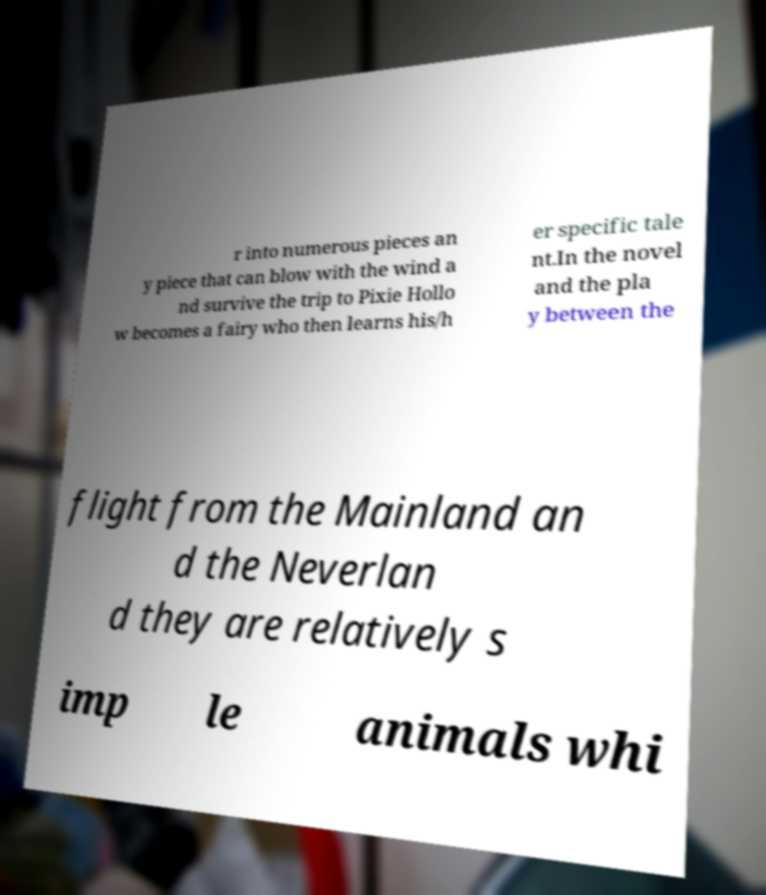For documentation purposes, I need the text within this image transcribed. Could you provide that? r into numerous pieces an y piece that can blow with the wind a nd survive the trip to Pixie Hollo w becomes a fairy who then learns his/h er specific tale nt.In the novel and the pla y between the flight from the Mainland an d the Neverlan d they are relatively s imp le animals whi 